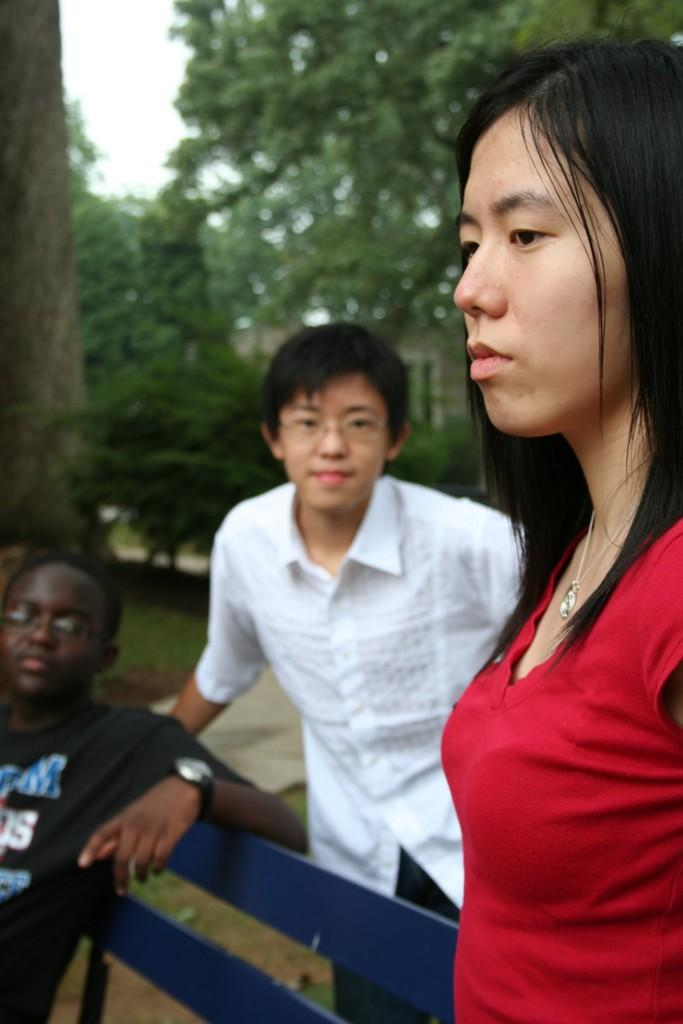How many people are present in the image? There are three people in the image. Where are the people located in the image? Two people are standing on the right side of the image, and one person is sitting on the left side of the image. What can be seen in the background of the image? There are trees visible in the background of the image. Is the hill covered in grain in the image? There is no hill or grain present in the image. 